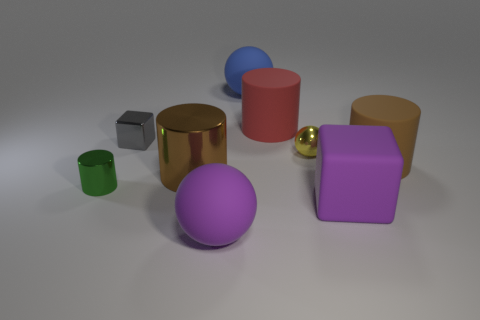Subtract all big cylinders. How many cylinders are left? 1 Subtract all gray spheres. How many brown cylinders are left? 2 Subtract all green cylinders. How many cylinders are left? 3 Subtract all cubes. How many objects are left? 7 Subtract 1 balls. How many balls are left? 2 Subtract all green cylinders. Subtract all purple balls. How many cylinders are left? 3 Subtract all red balls. Subtract all red things. How many objects are left? 8 Add 4 big brown rubber cylinders. How many big brown rubber cylinders are left? 5 Add 4 gray cubes. How many gray cubes exist? 5 Subtract 0 brown cubes. How many objects are left? 9 